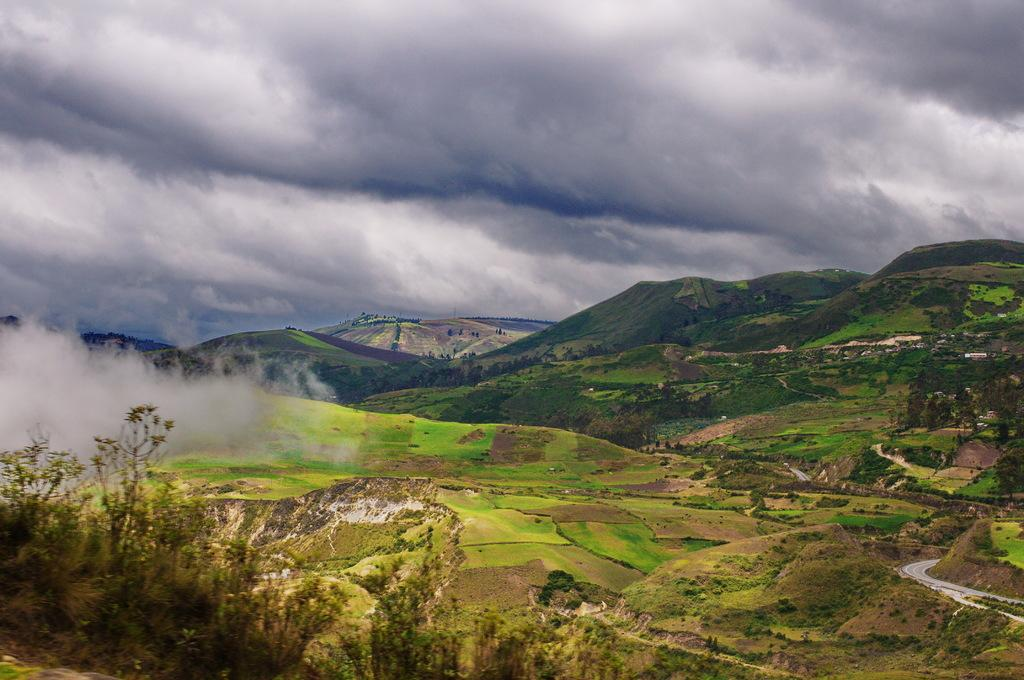What can be seen in the sky in the background of the image? There are clouds in the sky in the background of the image. What type of natural landform is visible in the image? Hills are visible in the image. What type of vegetation is present in the image? Trees are present in the image. What is the thicket in the image? The thicket is a dense growth of trees or shrubs visible in the image. What type of flame can be seen in the image? There is no flame present in the image. What is the aftermath of the event in the image? There is no event or aftermath depicted in the image; it features clouds, hills, trees, and a thicket. 